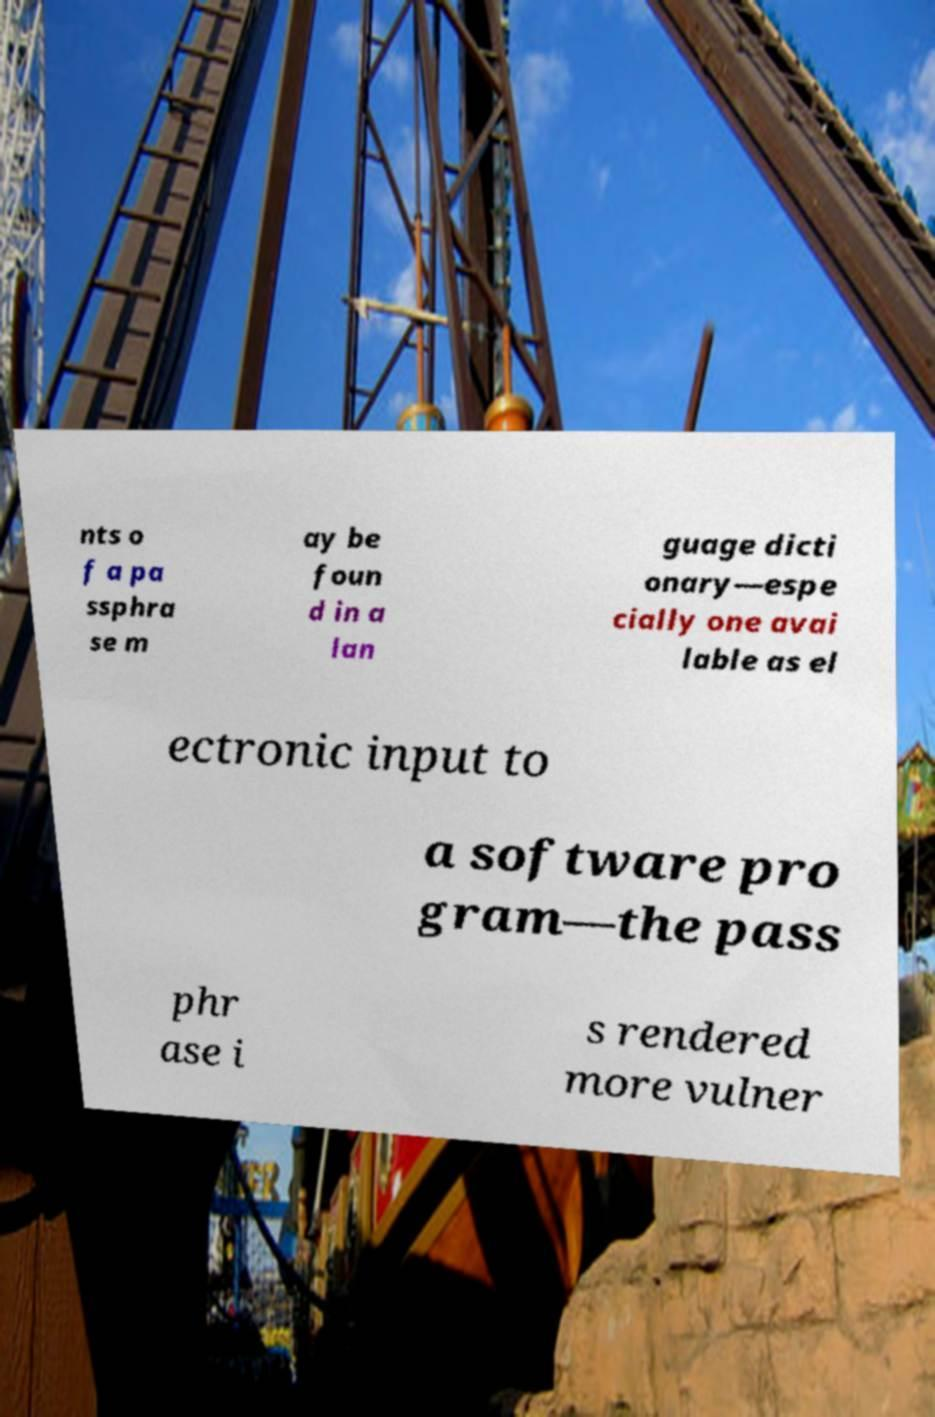Could you extract and type out the text from this image? nts o f a pa ssphra se m ay be foun d in a lan guage dicti onary—espe cially one avai lable as el ectronic input to a software pro gram—the pass phr ase i s rendered more vulner 